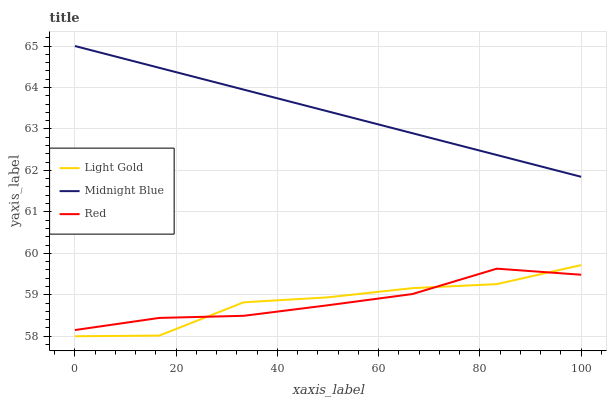Does Light Gold have the minimum area under the curve?
Answer yes or no. Yes. Does Midnight Blue have the maximum area under the curve?
Answer yes or no. Yes. Does Red have the minimum area under the curve?
Answer yes or no. No. Does Red have the maximum area under the curve?
Answer yes or no. No. Is Midnight Blue the smoothest?
Answer yes or no. Yes. Is Light Gold the roughest?
Answer yes or no. Yes. Is Red the smoothest?
Answer yes or no. No. Is Red the roughest?
Answer yes or no. No. Does Light Gold have the lowest value?
Answer yes or no. Yes. Does Red have the lowest value?
Answer yes or no. No. Does Midnight Blue have the highest value?
Answer yes or no. Yes. Does Red have the highest value?
Answer yes or no. No. Is Light Gold less than Midnight Blue?
Answer yes or no. Yes. Is Midnight Blue greater than Light Gold?
Answer yes or no. Yes. Does Light Gold intersect Red?
Answer yes or no. Yes. Is Light Gold less than Red?
Answer yes or no. No. Is Light Gold greater than Red?
Answer yes or no. No. Does Light Gold intersect Midnight Blue?
Answer yes or no. No. 